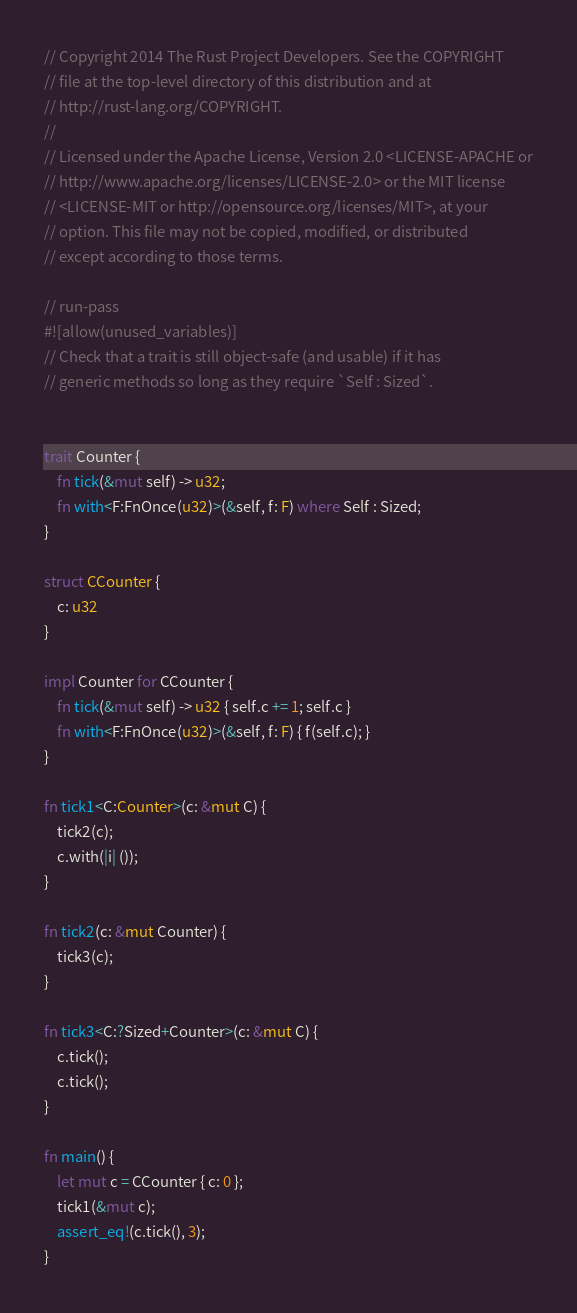Convert code to text. <code><loc_0><loc_0><loc_500><loc_500><_Rust_>// Copyright 2014 The Rust Project Developers. See the COPYRIGHT
// file at the top-level directory of this distribution and at
// http://rust-lang.org/COPYRIGHT.
//
// Licensed under the Apache License, Version 2.0 <LICENSE-APACHE or
// http://www.apache.org/licenses/LICENSE-2.0> or the MIT license
// <LICENSE-MIT or http://opensource.org/licenses/MIT>, at your
// option. This file may not be copied, modified, or distributed
// except according to those terms.

// run-pass
#![allow(unused_variables)]
// Check that a trait is still object-safe (and usable) if it has
// generic methods so long as they require `Self : Sized`.


trait Counter {
    fn tick(&mut self) -> u32;
    fn with<F:FnOnce(u32)>(&self, f: F) where Self : Sized;
}

struct CCounter {
    c: u32
}

impl Counter for CCounter {
    fn tick(&mut self) -> u32 { self.c += 1; self.c }
    fn with<F:FnOnce(u32)>(&self, f: F) { f(self.c); }
}

fn tick1<C:Counter>(c: &mut C) {
    tick2(c);
    c.with(|i| ());
}

fn tick2(c: &mut Counter) {
    tick3(c);
}

fn tick3<C:?Sized+Counter>(c: &mut C) {
    c.tick();
    c.tick();
}

fn main() {
    let mut c = CCounter { c: 0 };
    tick1(&mut c);
    assert_eq!(c.tick(), 3);
}
</code> 